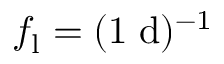Convert formula to latex. <formula><loc_0><loc_0><loc_500><loc_500>f _ { l } = ( 1 \, d ) ^ { - 1 }</formula> 